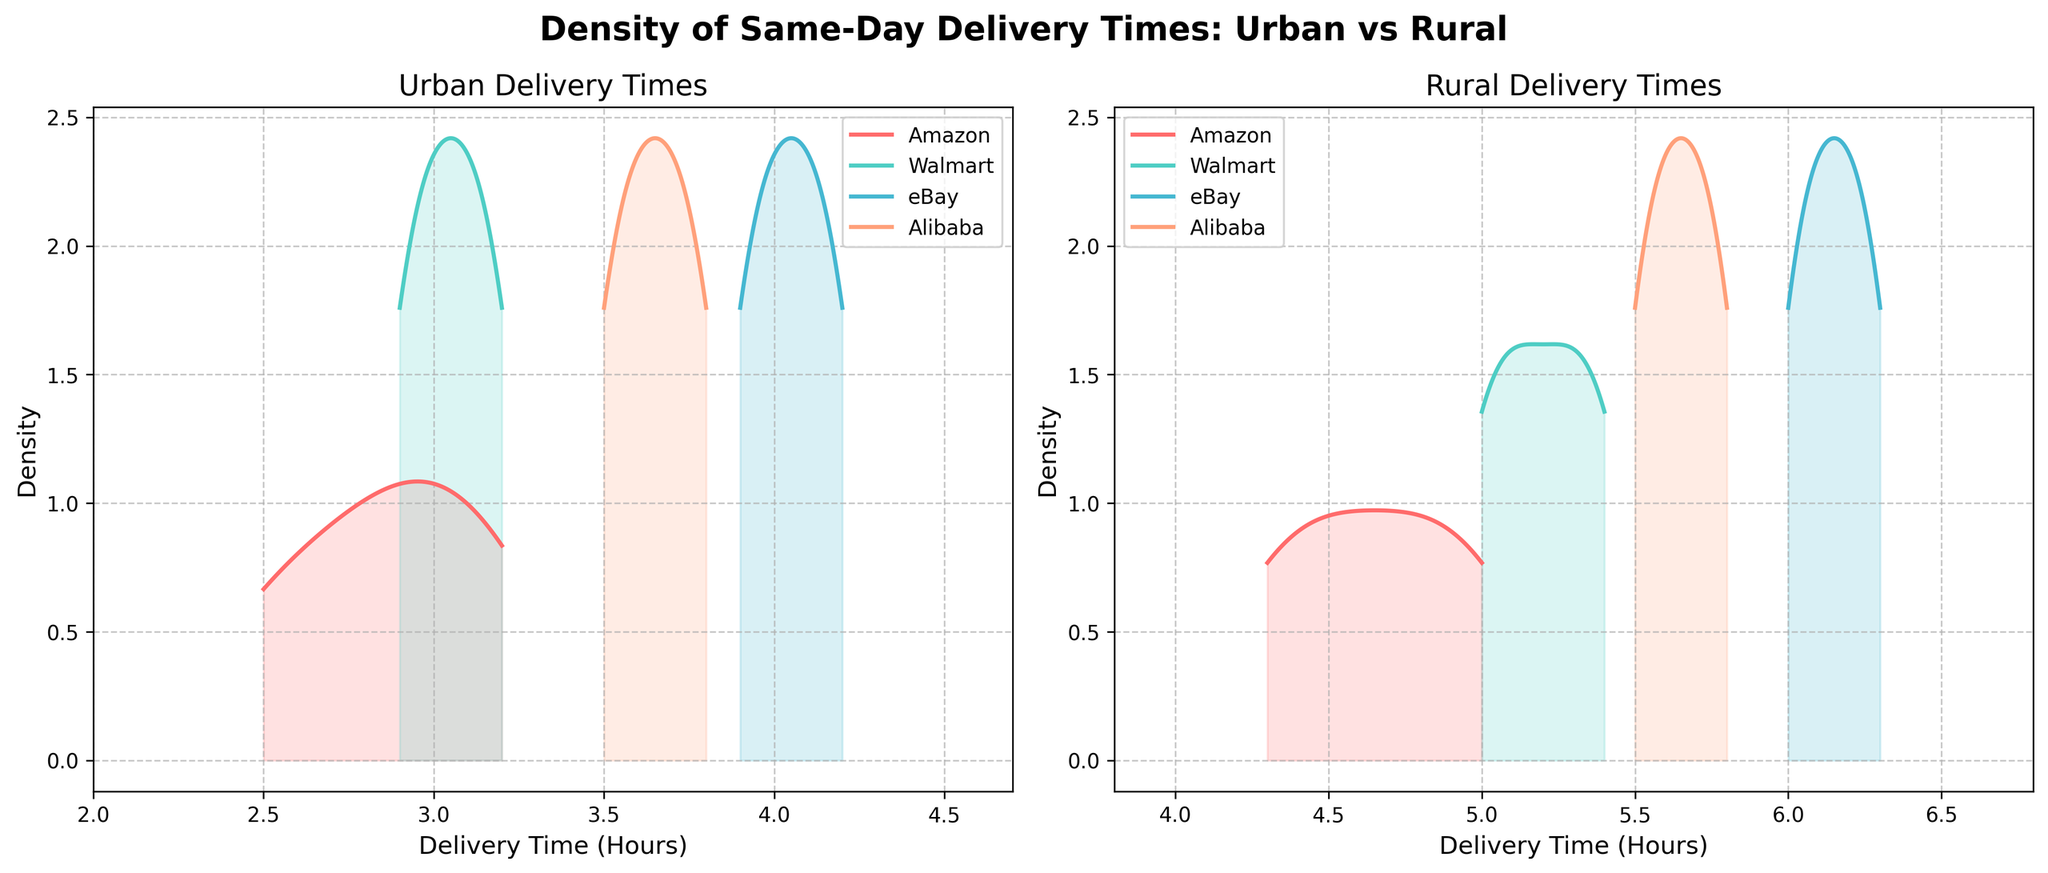Which region shows faster delivery times overall? The Urban plots for all companies generally peak earlier (lower delivery times) compared to the Rural plots, indicating faster delivery times in urban areas.
Answer: Urban Which company has the longest same-day delivery times in rural areas? The density plot for eBay in Rural areas peaks at the highest hours compared to all other companies, meaning eBay has the longest same-day delivery times in rural regions.
Answer: eBay What is the range of delivery times for Amazon in urban areas? Amazon's Urban density plot spans from around 2.5 hours to approximately 3.2 hours.
Answer: 2.5 to 3.2 hours Which company shows the smallest variation in delivery times in urban areas? By looking at the sharpest and narrowest peak, Walmart has the narrowest range in its Urban delivery time density plot, indicating the smallest variation.
Answer: Walmart For which region do the plots for all companies show more varied delivery times? The Rural region density plots are more spread out horizontally compared to the Urban plots, indicating more varied delivery times in Rural areas.
Answer: Rural Which company's delivery distribution in rural areas is centered around 5.5 hours? In the Rural subplot, Alibaba's plot shows a peak around 5.5 to 5.7 hours.
Answer: Alibaba Compare the peak delivery time for Walmart in urban versus rural areas. Walmart's density plot in the Urban area peaks around 3.0 hours whereas in the Rural area it peaks around 5.2 to 5.4 hours, showing a longer delivery time in rural areas.
Answer: Urban: 3.0 hours, Rural: 5.2 to 5.4 hours Between Amazon and Alibaba, which company has faster delivery times in rural areas? The density plot for Amazon in rural areas peaks around 4.5 to 4.8 hours, while Alibaba peaks around 5.5 to 5.8 hours, indicating Amazon has faster delivery times in rural areas.
Answer: Amazon Which region has a wider range of delivery times for eBay? eBay's Urban density plot shows a narrower peak (around 3.9 to 4.2 hours) compared to its Rural plot which spans from 6.0 to 6.3 hours, thus showing a wider range in Rural areas.
Answer: Rural 